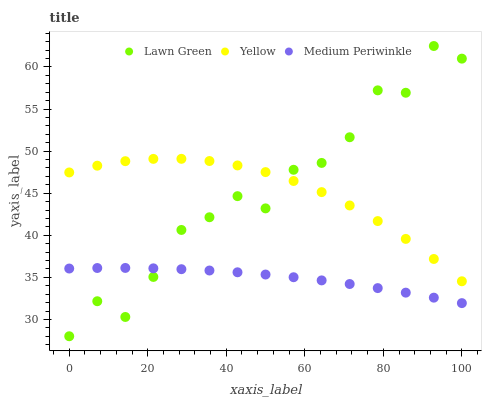Does Medium Periwinkle have the minimum area under the curve?
Answer yes or no. Yes. Does Lawn Green have the maximum area under the curve?
Answer yes or no. Yes. Does Yellow have the minimum area under the curve?
Answer yes or no. No. Does Yellow have the maximum area under the curve?
Answer yes or no. No. Is Medium Periwinkle the smoothest?
Answer yes or no. Yes. Is Lawn Green the roughest?
Answer yes or no. Yes. Is Yellow the smoothest?
Answer yes or no. No. Is Yellow the roughest?
Answer yes or no. No. Does Lawn Green have the lowest value?
Answer yes or no. Yes. Does Medium Periwinkle have the lowest value?
Answer yes or no. No. Does Lawn Green have the highest value?
Answer yes or no. Yes. Does Yellow have the highest value?
Answer yes or no. No. Is Medium Periwinkle less than Yellow?
Answer yes or no. Yes. Is Yellow greater than Medium Periwinkle?
Answer yes or no. Yes. Does Lawn Green intersect Yellow?
Answer yes or no. Yes. Is Lawn Green less than Yellow?
Answer yes or no. No. Is Lawn Green greater than Yellow?
Answer yes or no. No. Does Medium Periwinkle intersect Yellow?
Answer yes or no. No. 